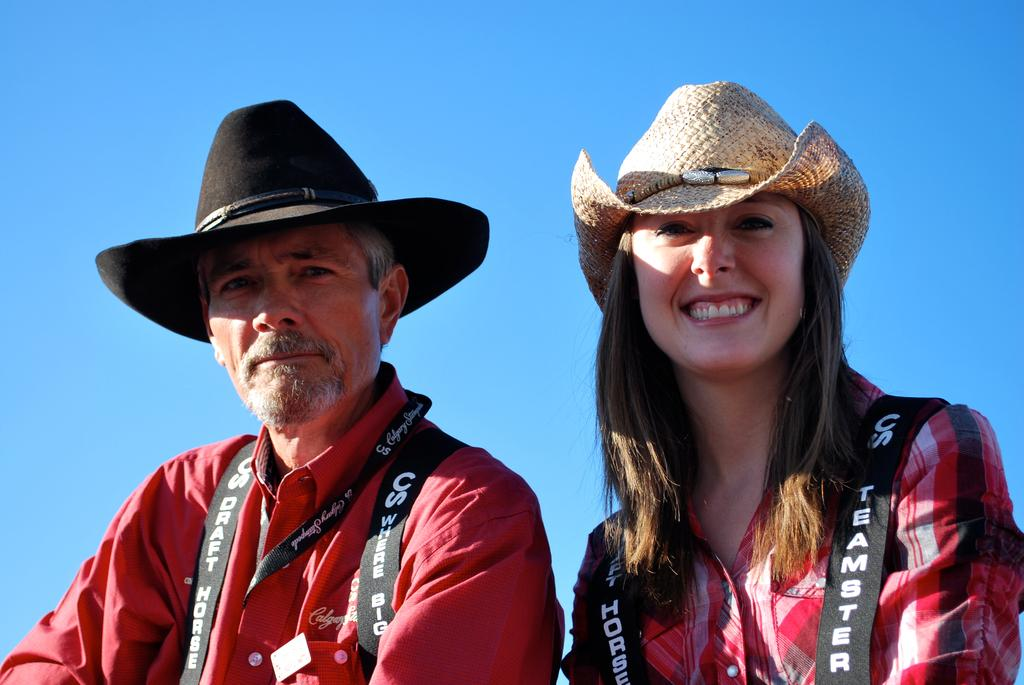Who are the people in the foreground of the picture? There is a man and a woman in the foreground of the picture. What are the man and the woman wearing on their heads? Both the man and the woman are wearing hats. What color shirts are the man and the woman wearing? Both the man and the woman are wearing red color shirts. What is the condition of the sky in the picture? The sky is clear in the picture. What is the weather like in the image? It is sunny in the image. What type of knowledge can be seen being shared between the man and the woman in the image? There is no indication of knowledge sharing or any specific activity between the man and the woman in the image. 